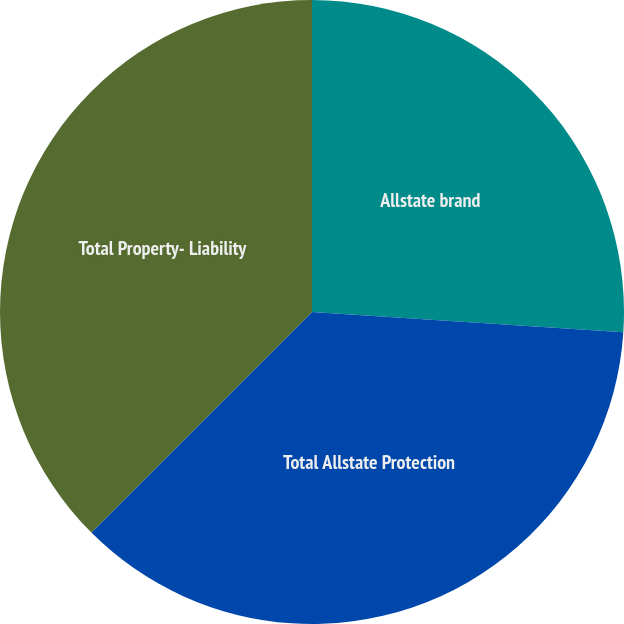Convert chart to OTSL. <chart><loc_0><loc_0><loc_500><loc_500><pie_chart><fcel>Allstate brand<fcel>Total Allstate Protection<fcel>Total Property- Liability<nl><fcel>26.04%<fcel>36.46%<fcel>37.5%<nl></chart> 